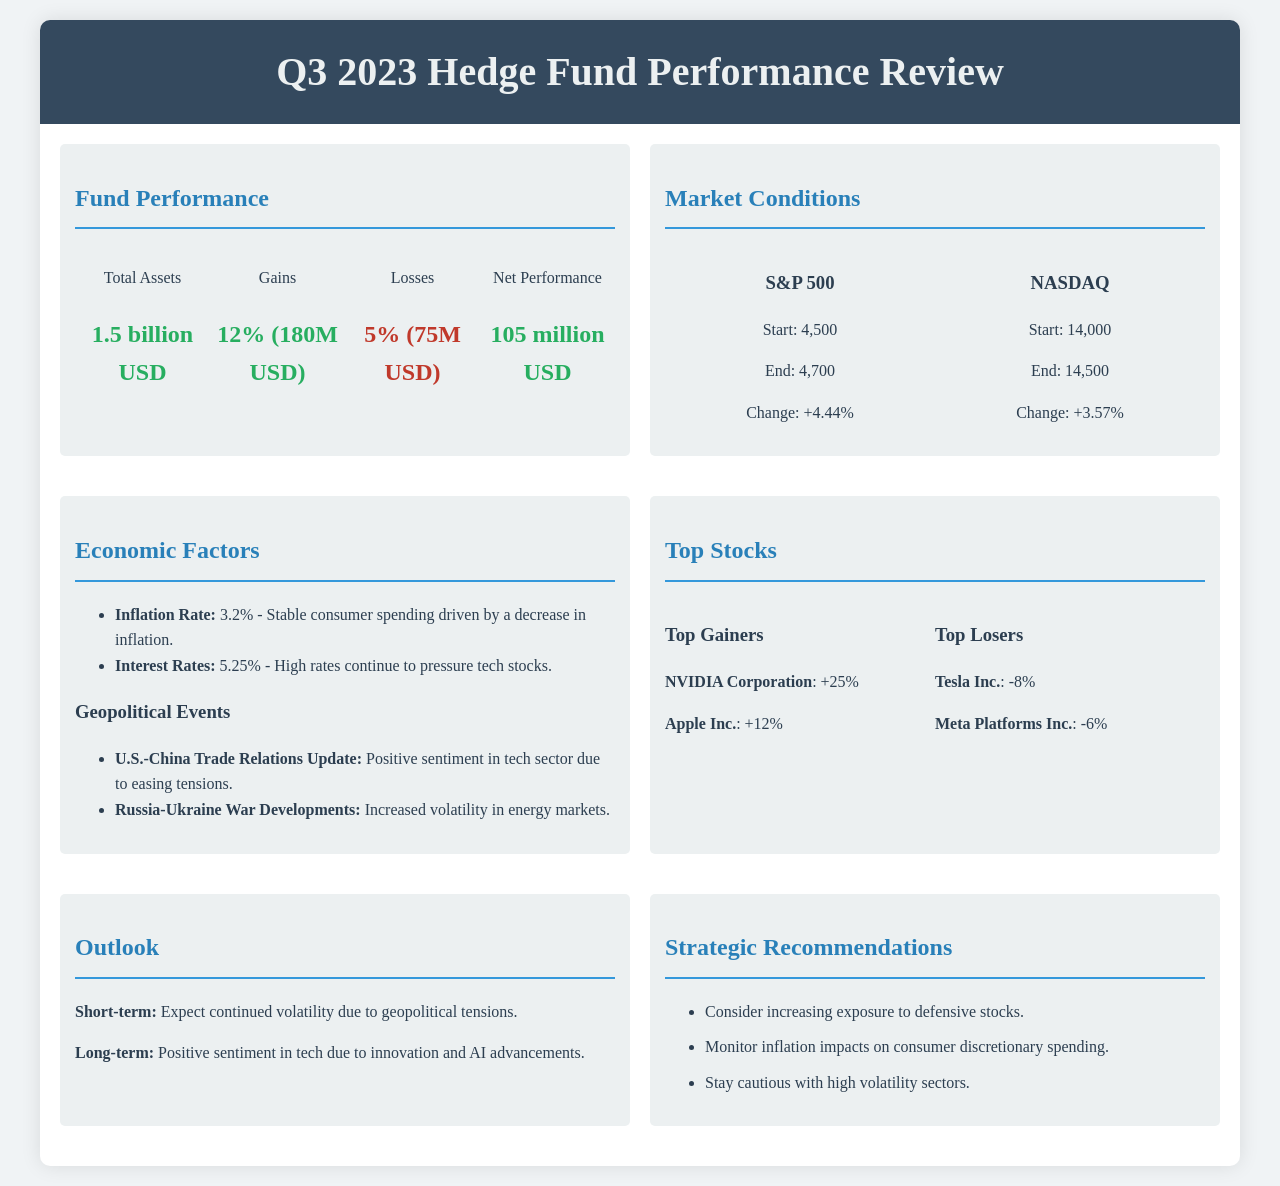What is the total asset of the hedge fund? The total asset is stated in the performance section of the document, which shows the amount as 1.5 billion USD.
Answer: 1.5 billion USD What was the net performance for Q3 2023? The net performance is mentioned in the fund performance section, listed as 105 million USD.
Answer: 105 million USD What percentage of gains did the hedge fund experience? The performance section specifies that the gains were 12% for the quarter.
Answer: 12% What was the change in the S&P 500? The market conditions section indicates a change of +4.44% for the S&P 500.
Answer: +4.44% Which stock had the highest gain in Q3 2023? The top gainers section lists NVIDIA Corporation with a gain of +25%.
Answer: NVIDIA Corporation What were the interest rates in Q3 2023? The economic factors section states that the interest rates were 5.25%.
Answer: 5.25% What is the outlook for the long term? The outlook section describes the long-term sentiment as positive due to innovation and AI advancements.
Answer: Positive sentiment in tech due to innovation and AI advancements What is one strategic recommendation provided in the document? The strategic recommendations section lists several options, including increasing exposure to defensive stocks.
Answer: Consider increasing exposure to defensive stocks What was the percentage loss for Tesla Inc.? The top losers section specifies that Tesla Inc. had a loss of -8%.
Answer: -8% 